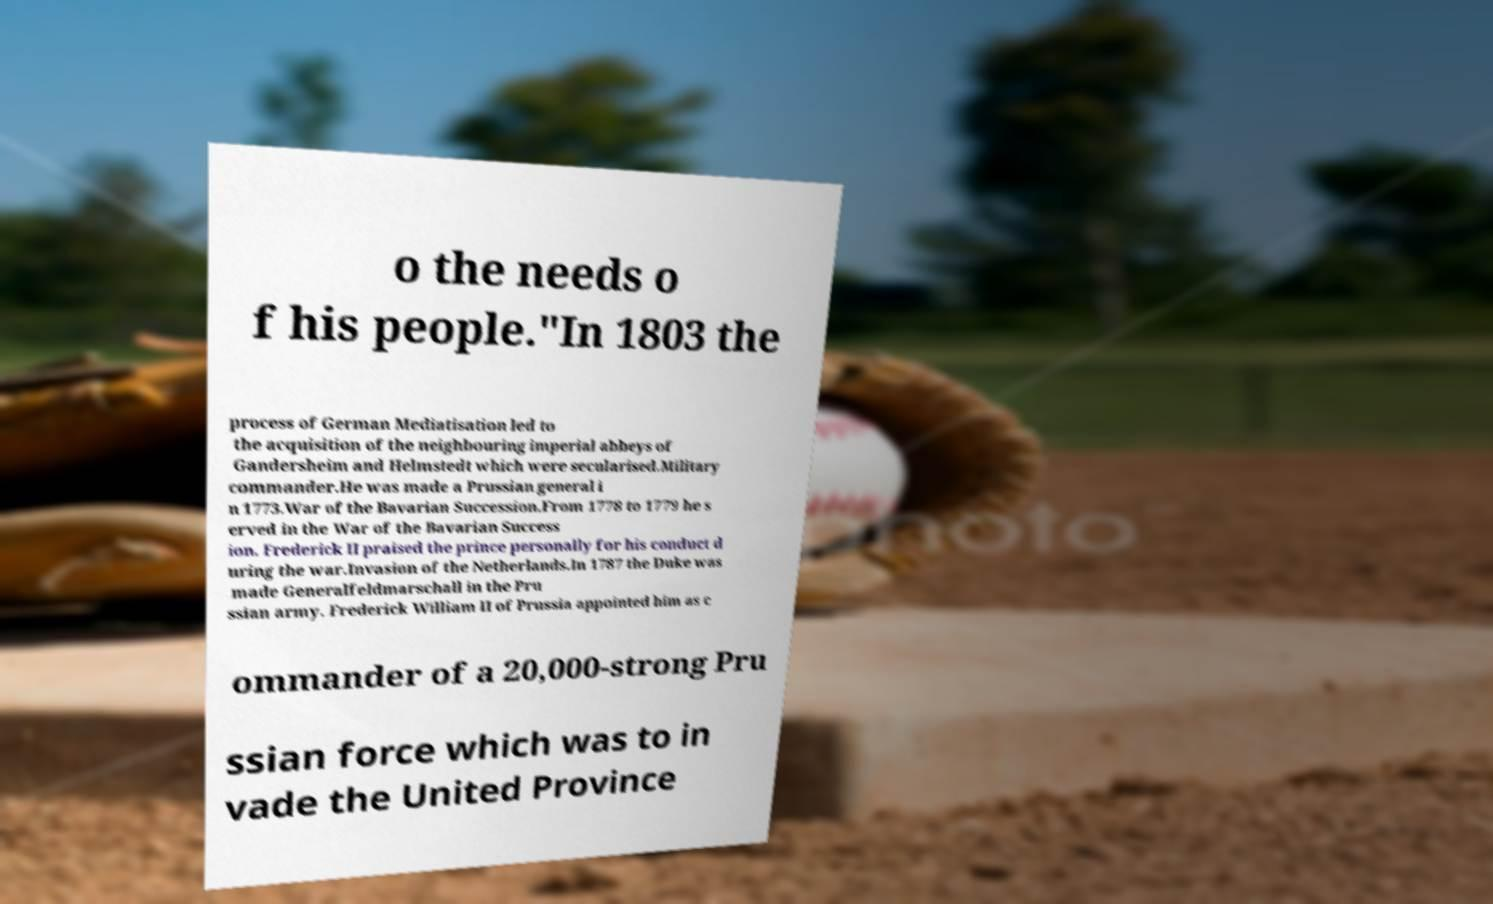Can you accurately transcribe the text from the provided image for me? o the needs o f his people."In 1803 the process of German Mediatisation led to the acquisition of the neighbouring imperial abbeys of Gandersheim and Helmstedt which were secularised.Military commander.He was made a Prussian general i n 1773.War of the Bavarian Succession.From 1778 to 1779 he s erved in the War of the Bavarian Success ion. Frederick II praised the prince personally for his conduct d uring the war.Invasion of the Netherlands.In 1787 the Duke was made Generalfeldmarschall in the Pru ssian army. Frederick William II of Prussia appointed him as c ommander of a 20,000-strong Pru ssian force which was to in vade the United Province 